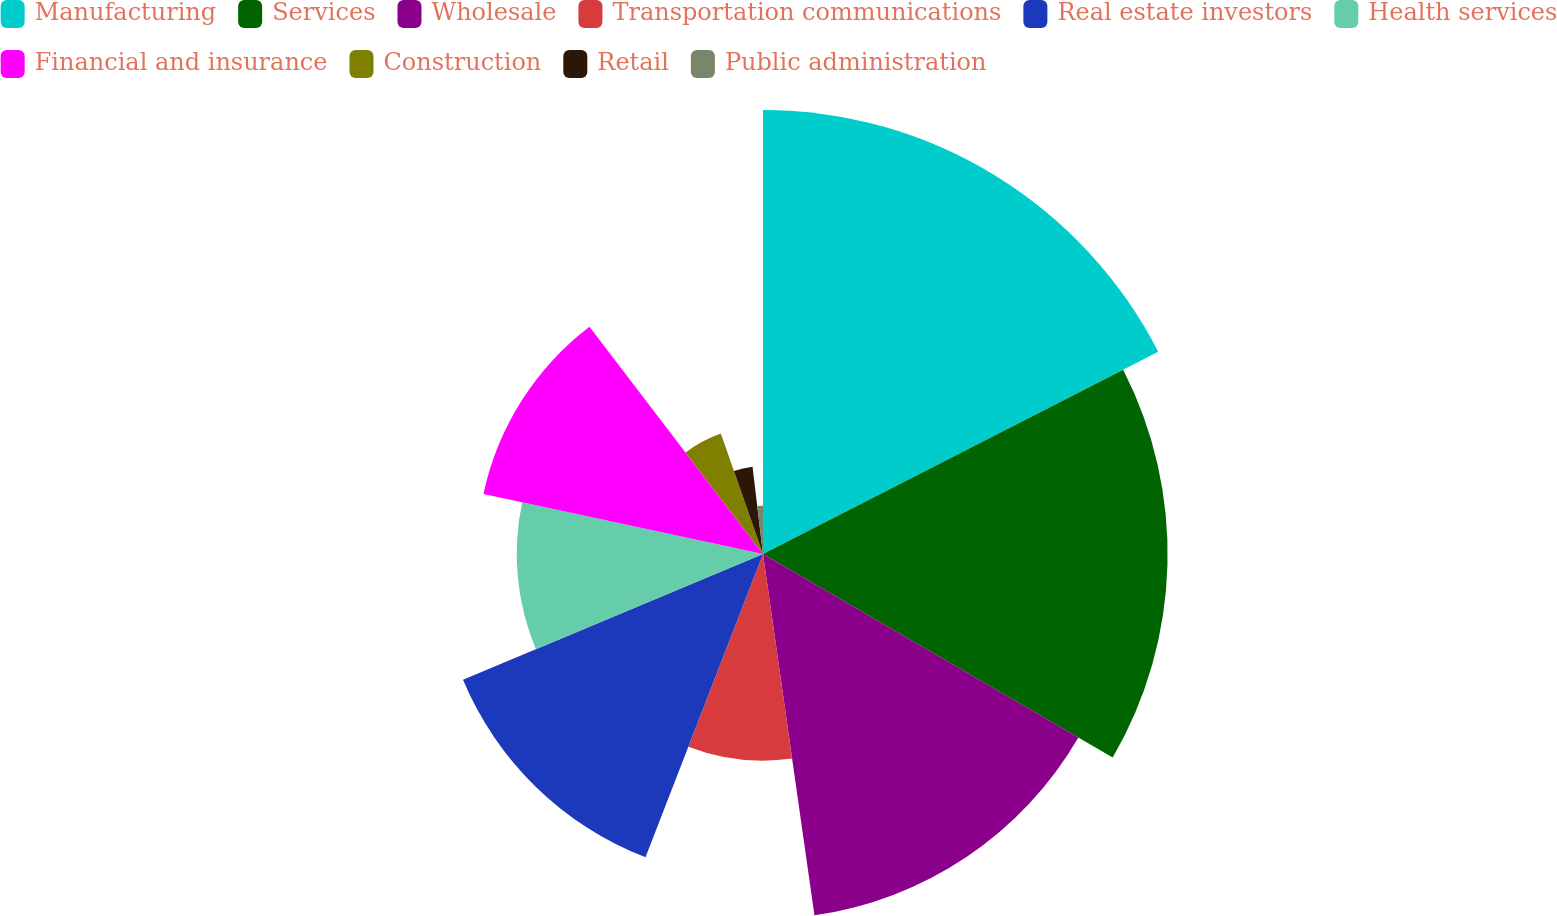Convert chart. <chart><loc_0><loc_0><loc_500><loc_500><pie_chart><fcel>Manufacturing<fcel>Services<fcel>Wholesale<fcel>Transportation communications<fcel>Real estate investors<fcel>Health services<fcel>Financial and insurance<fcel>Construction<fcel>Retail<fcel>Public administration<nl><fcel>17.47%<fcel>15.92%<fcel>14.36%<fcel>8.13%<fcel>12.8%<fcel>9.69%<fcel>11.25%<fcel>5.02%<fcel>3.46%<fcel>1.9%<nl></chart> 